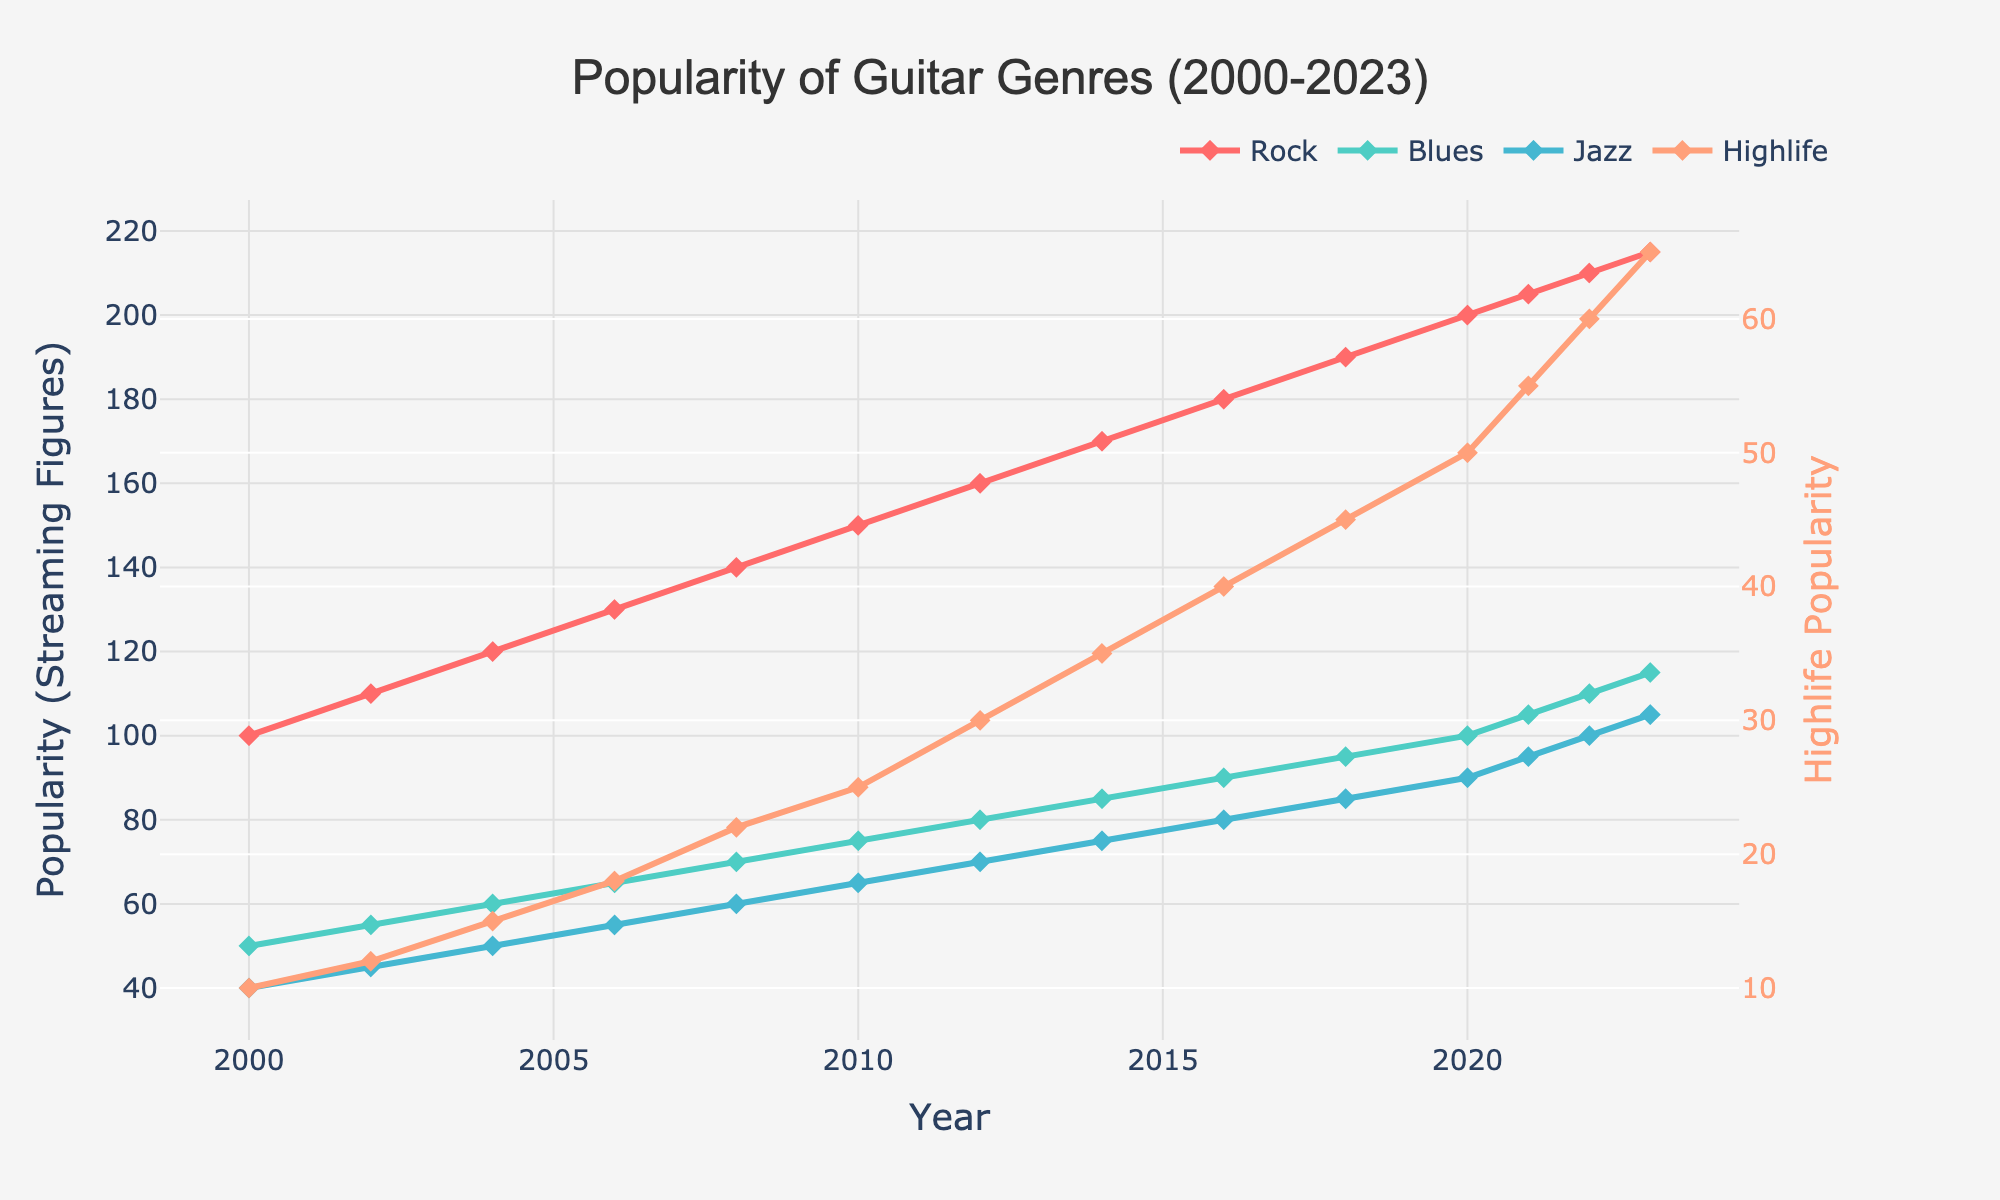Which genre was the most popular in 2023? By looking at the figure, it's clear that the genre with the highest value in 2023 is Rock.
Answer: Rock What was the popularity difference between Rock and Highlife in 2006? From the figure, the value for Rock in 2006 is 130 and for Highlife is 18. The difference is 130 - 18.
Answer: 112 Which year did Blues reach a popularity of 100? On inspecting the figure, Blues reached the popularity value of 100 in the year 2020.
Answer: 2020 How did the popularity of Jazz change from 2010 to 2020? Comparing the values from the figure, Jazz's popularity went from 65 in 2010 to 90 in 2020. So the change is 90 - 65.
Answer: Increased by 25 Between Rock and Blues, which had a higher increase in popularity from 2000 to 2023? For Rock, the value increased from 100 to 215 (increase of 115). For Blues, the value increased from 50 to 115 (increase of 65). Rock had the higher increase.
Answer: Rock In the year 2015, what was the average popularity of Rock, Blues, and Jazz? Since there is no data for the year 2015, we consider the surrounding years 2014 and 2016. The averages are taken as: For 2014: Rock = 170, Blues = 85, Jazz = 75. For 2016: Rock = 180, Blues = 90, Jazz = 80. Hence, averages for 2015 are Rock = 175, Blues = 87.5, Jazz = 77.5 and (175 + 87.5 + 77.5) / 3 results in 113.33.
Answer: 113.33 How much did the popularity of Highlife grow from 2000 to 2023? According to the figure, Highlife grew from 10 in 2000 to 65 in 2023. So the growth is 65 - 10.
Answer: 55 Which genre had the least popularity growth between 2008 and 2018? From the figure, the growth for each genre is calculated as: Rock = 190 - 140 = 50, Blues = 95 - 70 = 25, Jazz = 85 - 60 = 25, Highlife = 45 - 22 = 23. Highlife had the least growth.
Answer: Highlife 